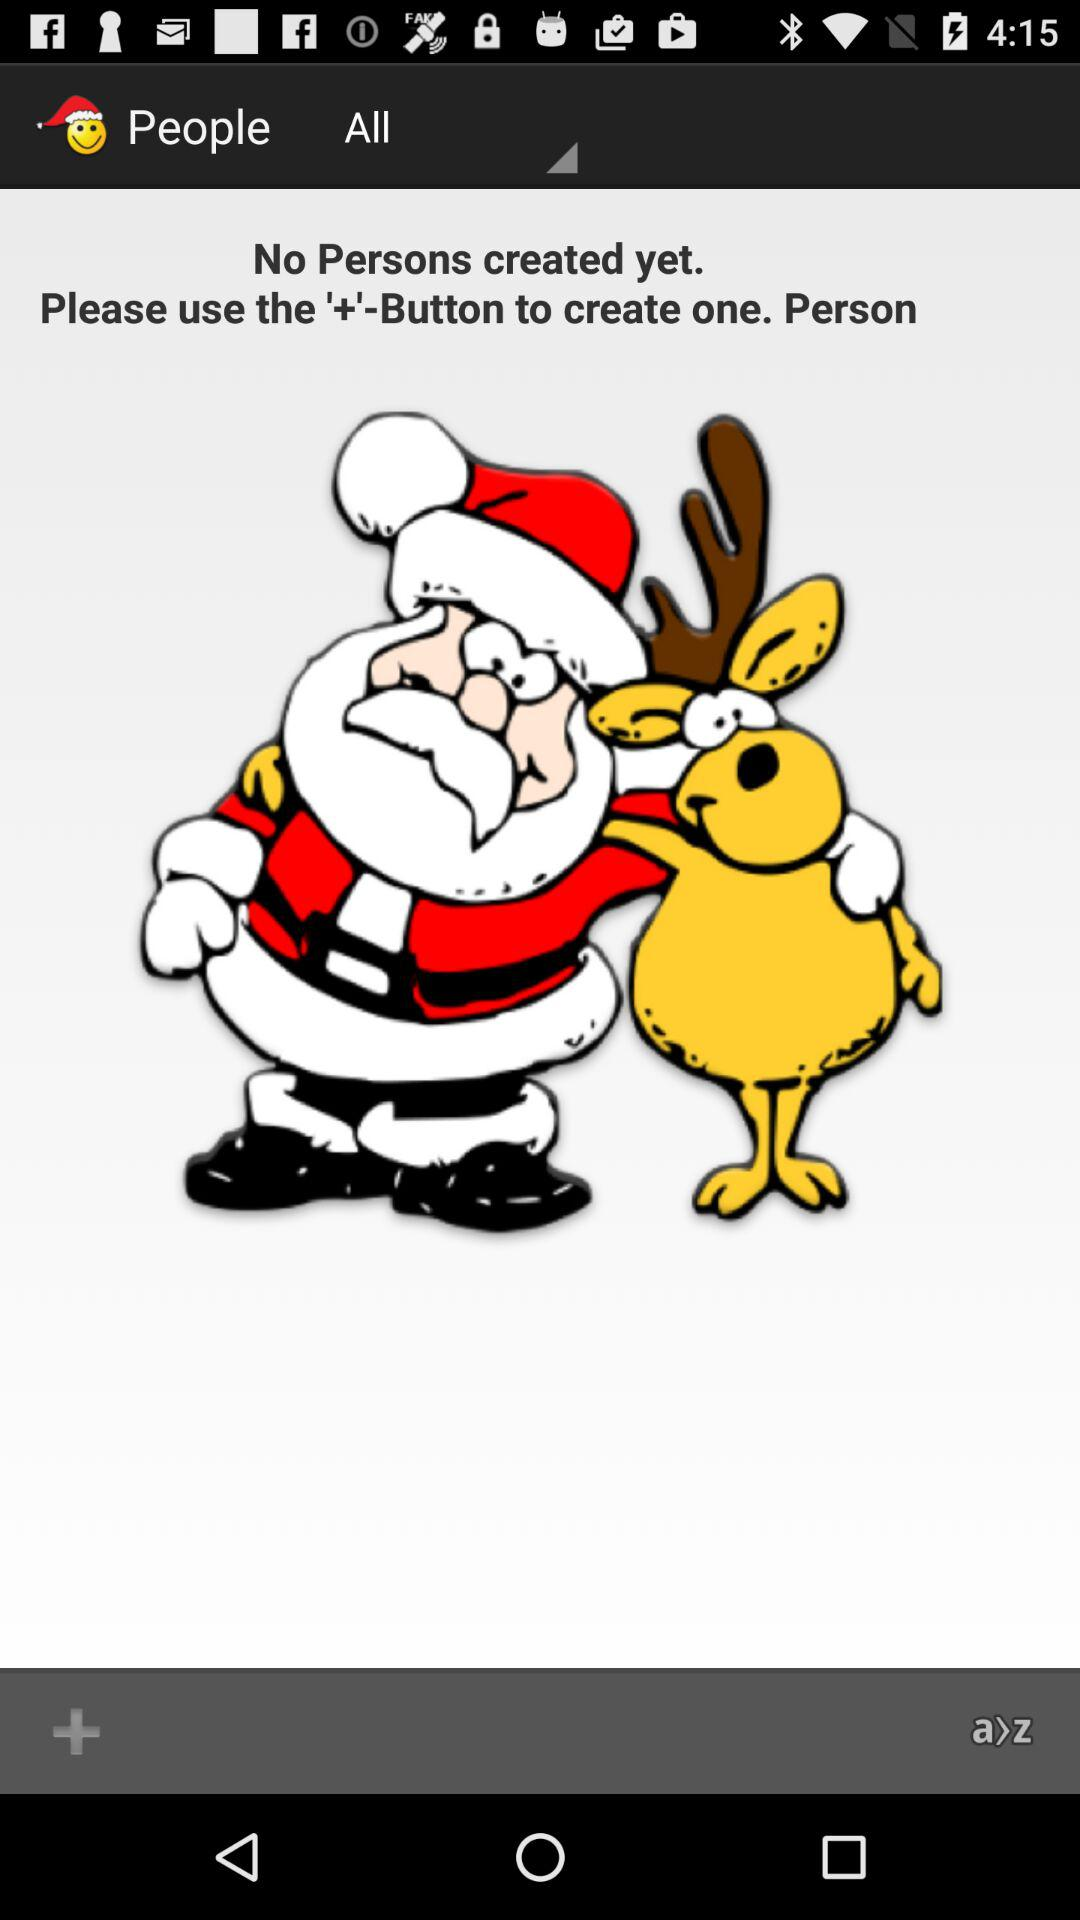What button can be used to create the person? The button that can be used to create the person is '+'. 